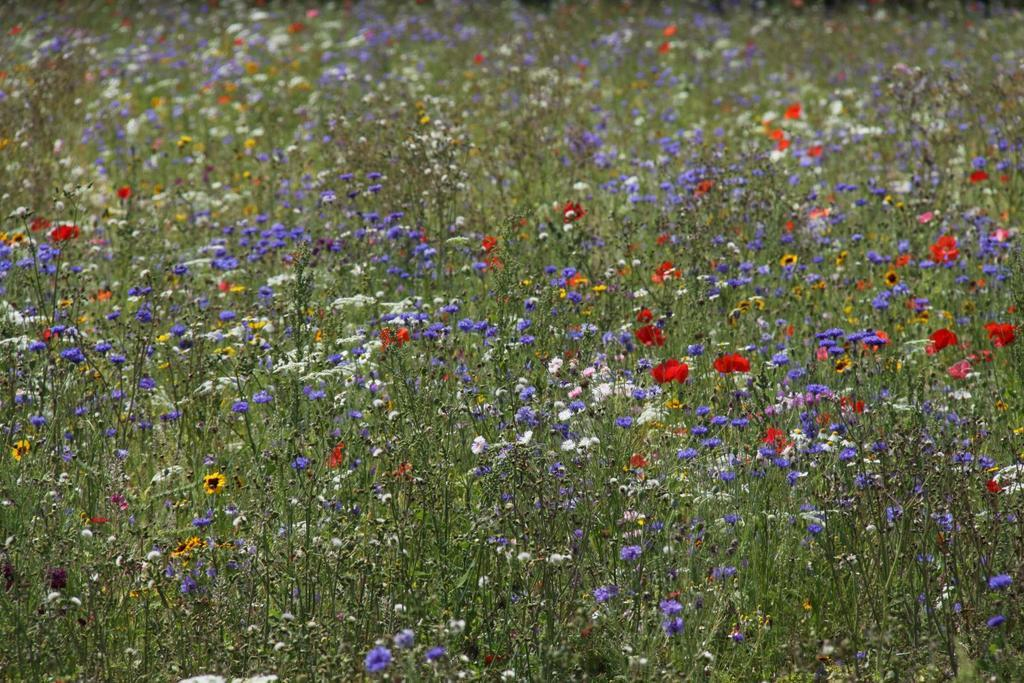What type of living organisms can be seen in the image? There are many plants in the image. What colors are the flowers in the image? There are red, yellow, white, and violet flowers in the image. What type of education can be seen in the image? There is no reference to education in the image; it features plants and flowers. How much money is visible in the image? There is no money present in the image. 